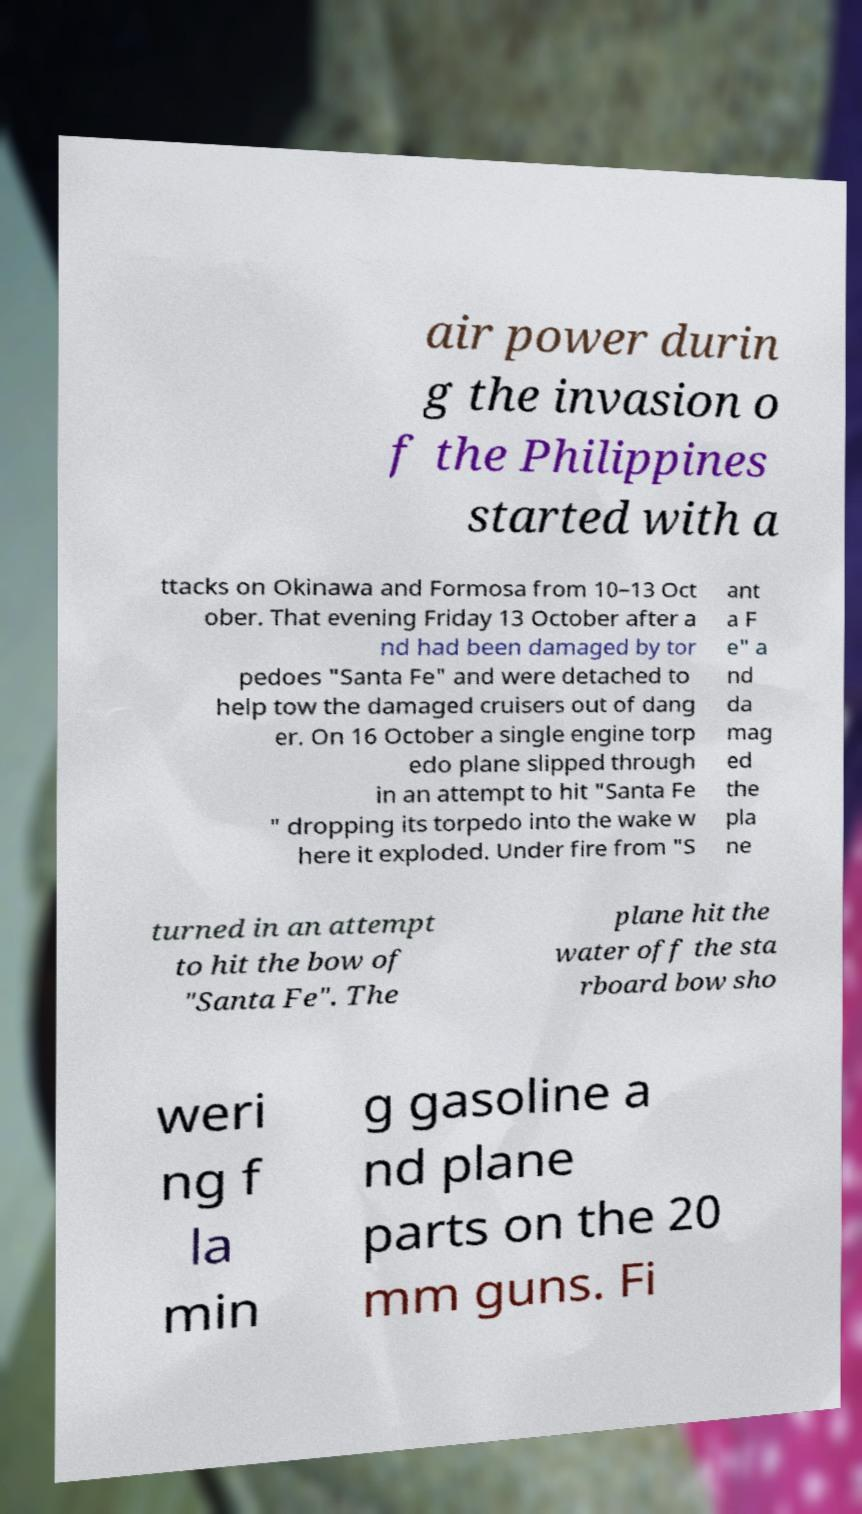For documentation purposes, I need the text within this image transcribed. Could you provide that? air power durin g the invasion o f the Philippines started with a ttacks on Okinawa and Formosa from 10–13 Oct ober. That evening Friday 13 October after a nd had been damaged by tor pedoes "Santa Fe" and were detached to help tow the damaged cruisers out of dang er. On 16 October a single engine torp edo plane slipped through in an attempt to hit "Santa Fe " dropping its torpedo into the wake w here it exploded. Under fire from "S ant a F e" a nd da mag ed the pla ne turned in an attempt to hit the bow of "Santa Fe". The plane hit the water off the sta rboard bow sho weri ng f la min g gasoline a nd plane parts on the 20 mm guns. Fi 